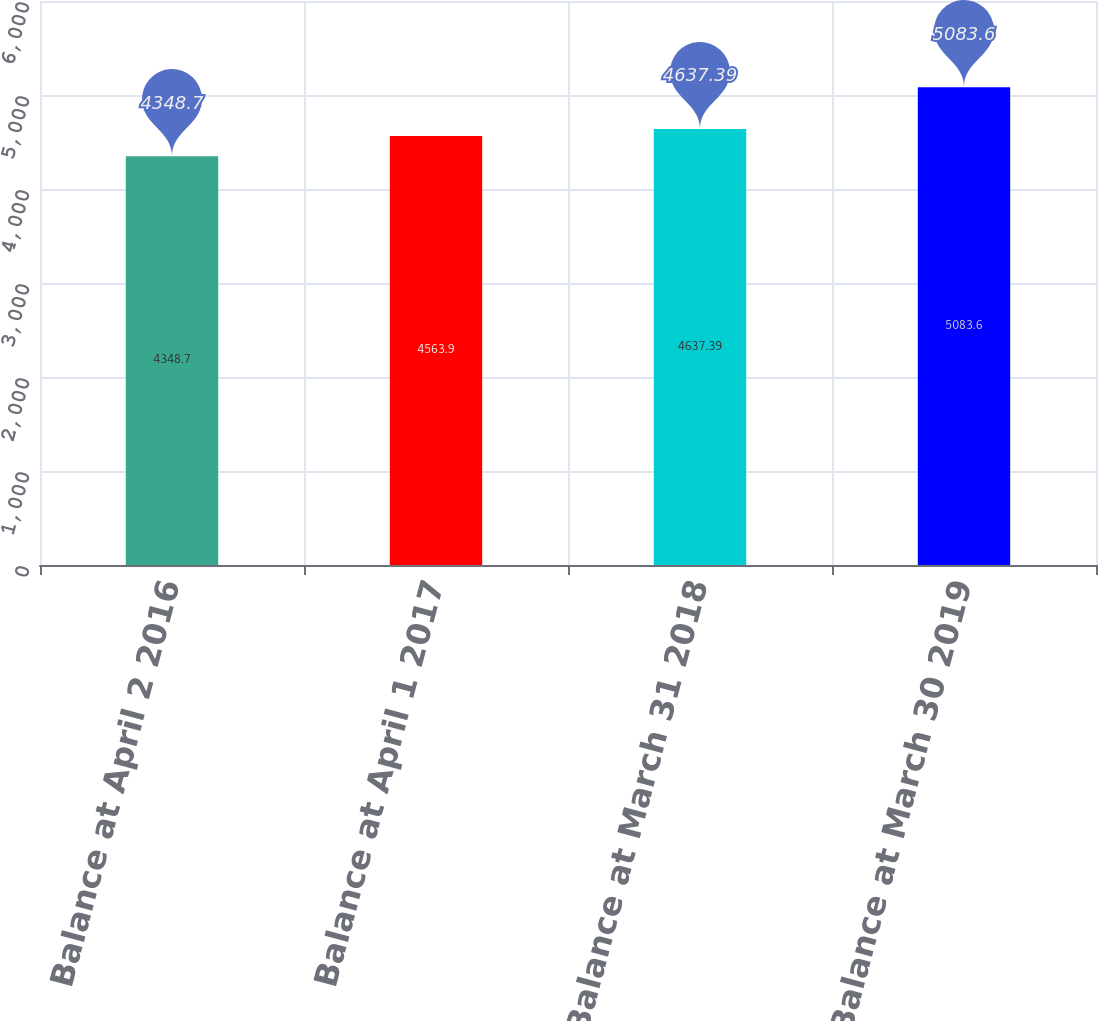Convert chart. <chart><loc_0><loc_0><loc_500><loc_500><bar_chart><fcel>Balance at April 2 2016<fcel>Balance at April 1 2017<fcel>Balance at March 31 2018<fcel>Balance at March 30 2019<nl><fcel>4348.7<fcel>4563.9<fcel>4637.39<fcel>5083.6<nl></chart> 